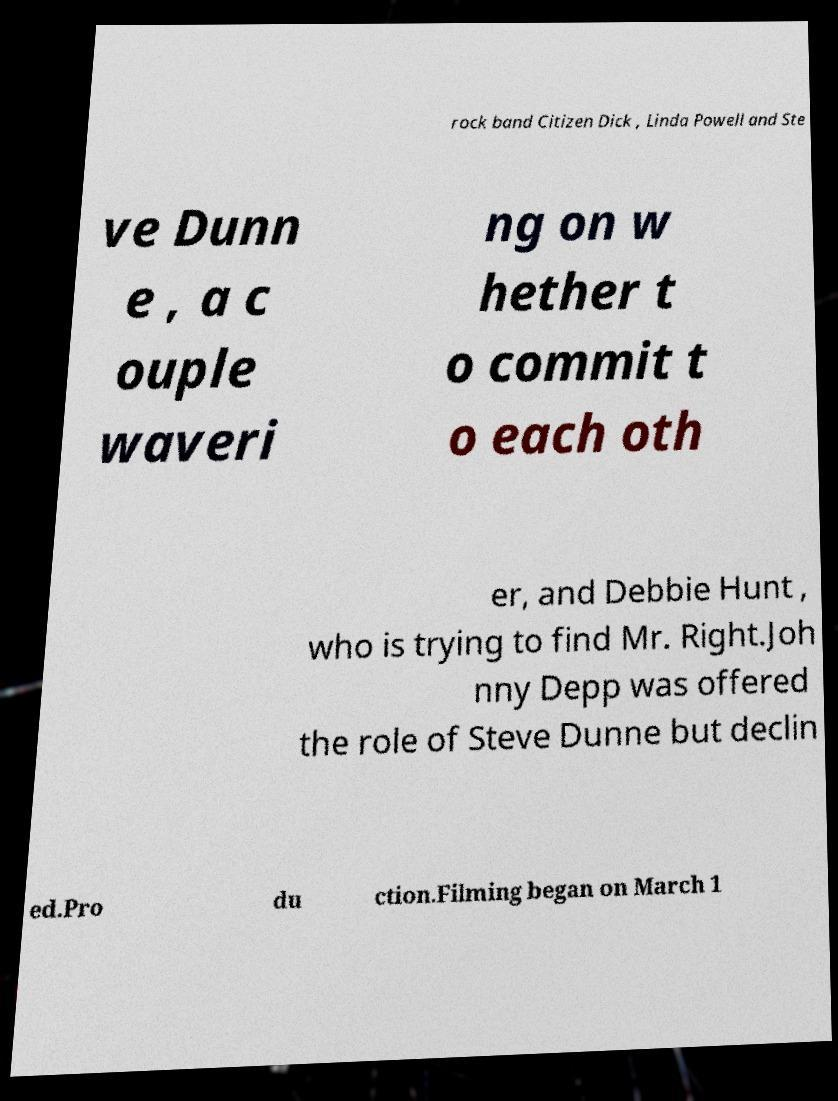Please identify and transcribe the text found in this image. rock band Citizen Dick , Linda Powell and Ste ve Dunn e , a c ouple waveri ng on w hether t o commit t o each oth er, and Debbie Hunt , who is trying to find Mr. Right.Joh nny Depp was offered the role of Steve Dunne but declin ed.Pro du ction.Filming began on March 1 